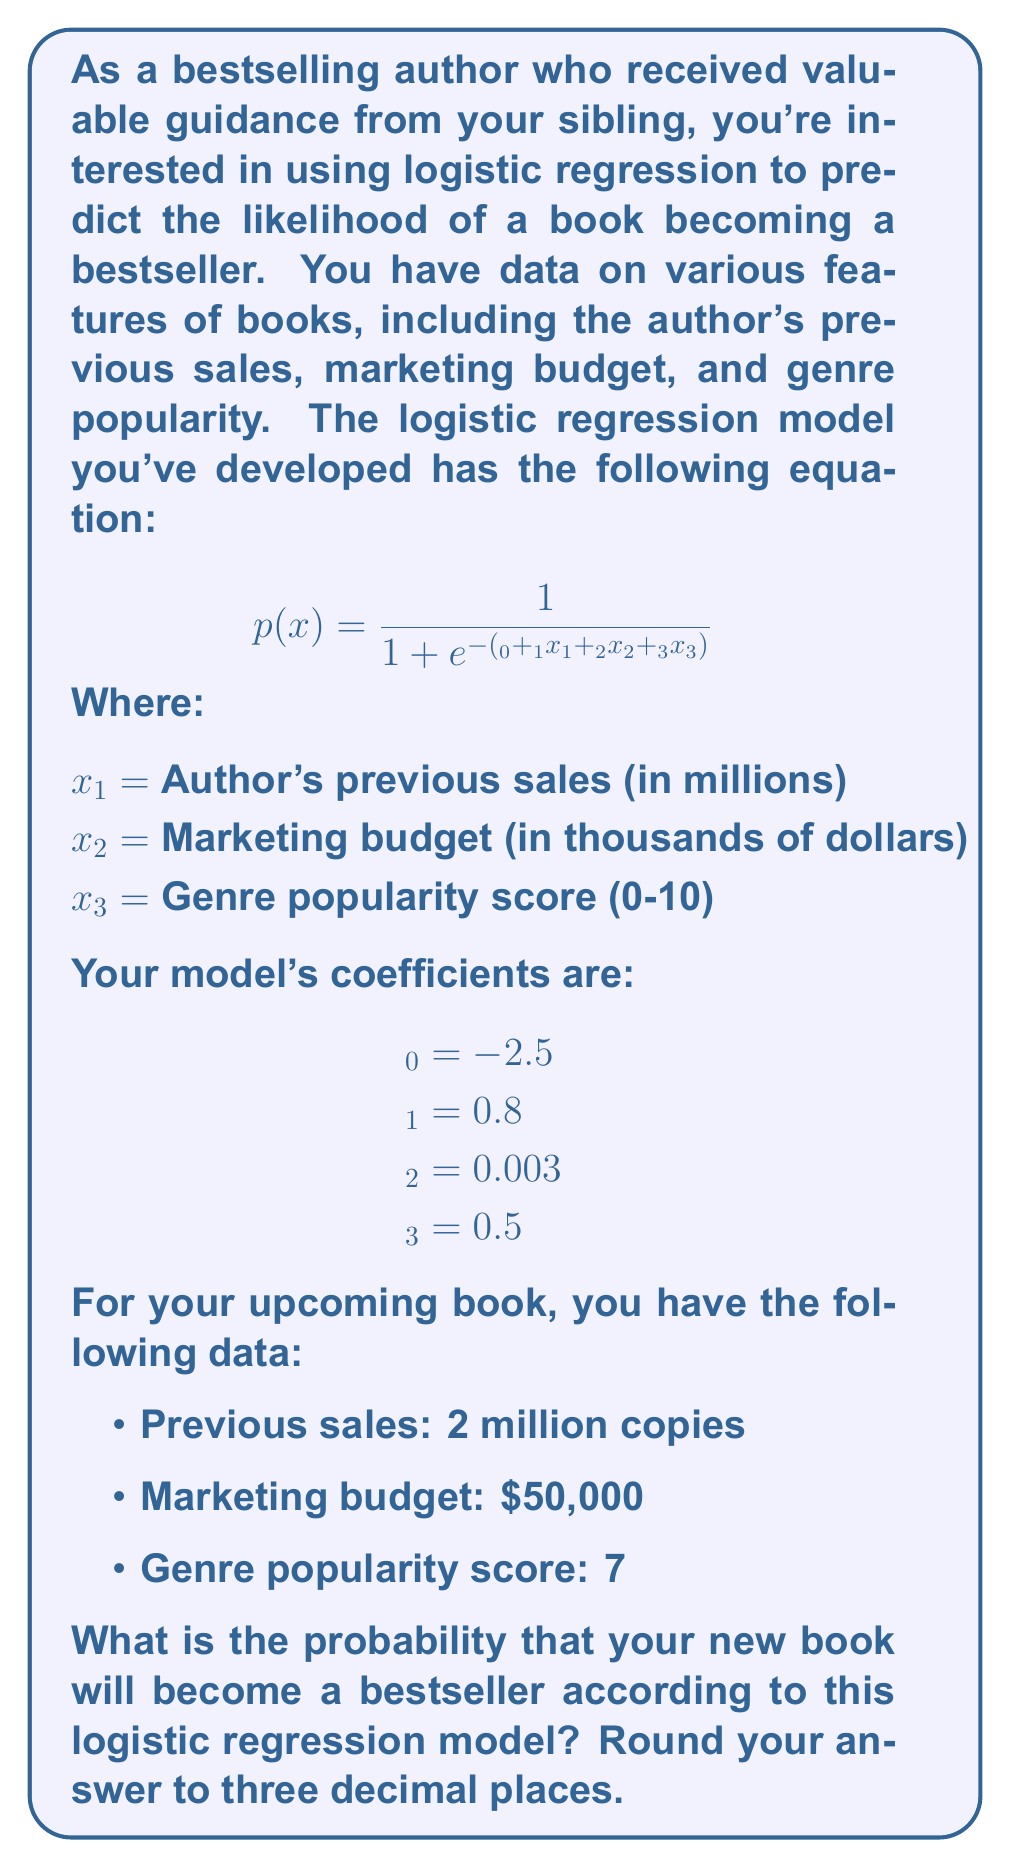Can you solve this math problem? To solve this problem, we'll follow these steps:

1. Identify the values for each variable:
   $x_1 = 2$ (previous sales in millions)
   $x_2 = 50$ (marketing budget in thousands)
   $x_3 = 7$ (genre popularity score)

2. Substitute these values and the given coefficients into the logistic regression equation:

   $$p(x) = \frac{1}{1 + e^{-(β_0 + β_1x_1 + β_2x_2 + β_3x_3)}}$$

   $$p(x) = \frac{1}{1 + e^{-(-2.5 + 0.8(2) + 0.003(50) + 0.5(7))}}$$

3. Calculate the expression inside the exponential:
   $-2.5 + 0.8(2) + 0.003(50) + 0.5(7)$
   $= -2.5 + 1.6 + 0.15 + 3.5$
   $= 2.75$

4. Simplify the equation:

   $$p(x) = \frac{1}{1 + e^{-2.75}}$$

5. Calculate $e^{-2.75}$ (you can use a calculator for this):
   $e^{-2.75} ≈ 0.0639$

6. Substitute this value into the equation:

   $$p(x) = \frac{1}{1 + 0.0639} = \frac{1}{1.0639}$$

7. Perform the final division:
   $1 / 1.0639 ≈ 0.9399$

8. Round to three decimal places:
   $0.940$
Answer: 0.940 